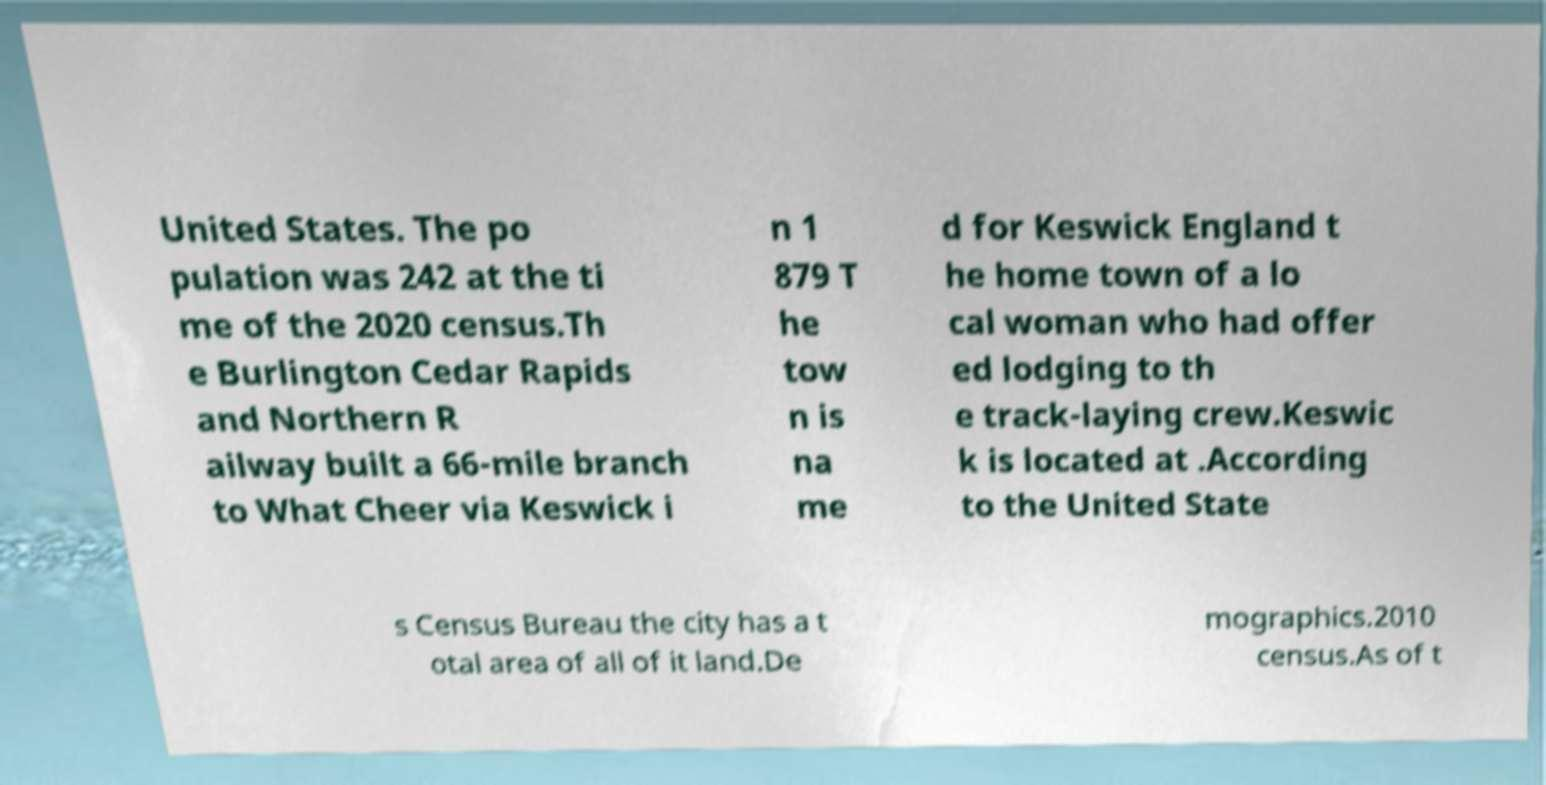What messages or text are displayed in this image? I need them in a readable, typed format. United States. The po pulation was 242 at the ti me of the 2020 census.Th e Burlington Cedar Rapids and Northern R ailway built a 66-mile branch to What Cheer via Keswick i n 1 879 T he tow n is na me d for Keswick England t he home town of a lo cal woman who had offer ed lodging to th e track-laying crew.Keswic k is located at .According to the United State s Census Bureau the city has a t otal area of all of it land.De mographics.2010 census.As of t 